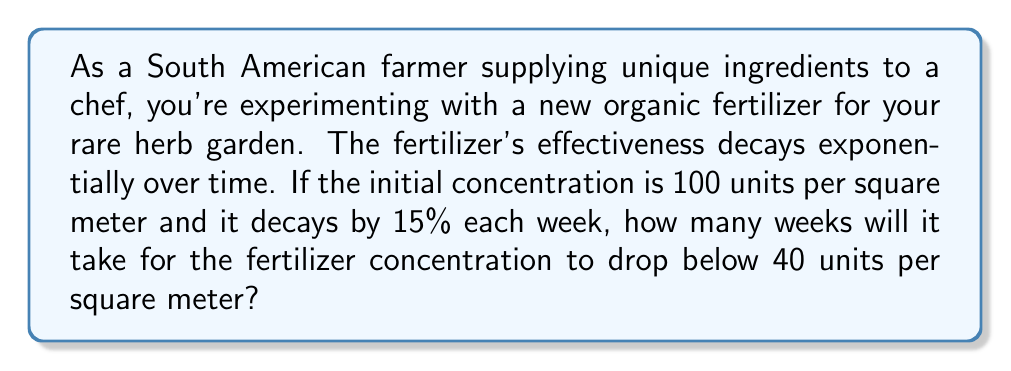What is the answer to this math problem? Let's approach this step-by-step using the exponential decay formula:

1) The exponential decay formula is:
   $$A(t) = A_0 \cdot (1-r)^t$$
   where:
   $A(t)$ is the amount at time $t$
   $A_0$ is the initial amount
   $r$ is the decay rate per time period
   $t$ is the number of time periods

2) We know:
   $A_0 = 100$ units
   $r = 0.15$ (15% decay rate)
   We want to find $t$ when $A(t) < 40$

3) Let's set up the inequality:
   $$40 > 100 \cdot (1-0.15)^t$$

4) Simplify:
   $$40 > 100 \cdot (0.85)^t$$

5) Divide both sides by 100:
   $$0.4 > (0.85)^t$$

6) Take the natural log of both sides:
   $$\ln(0.4) > t \cdot \ln(0.85)$$

7) Solve for $t$:
   $$t > \frac{\ln(0.4)}{\ln(0.85)} \approx 5.94$$

8) Since we need the number of whole weeks, we round up to the next integer.
Answer: It will take 6 weeks for the fertilizer concentration to drop below 40 units per square meter. 